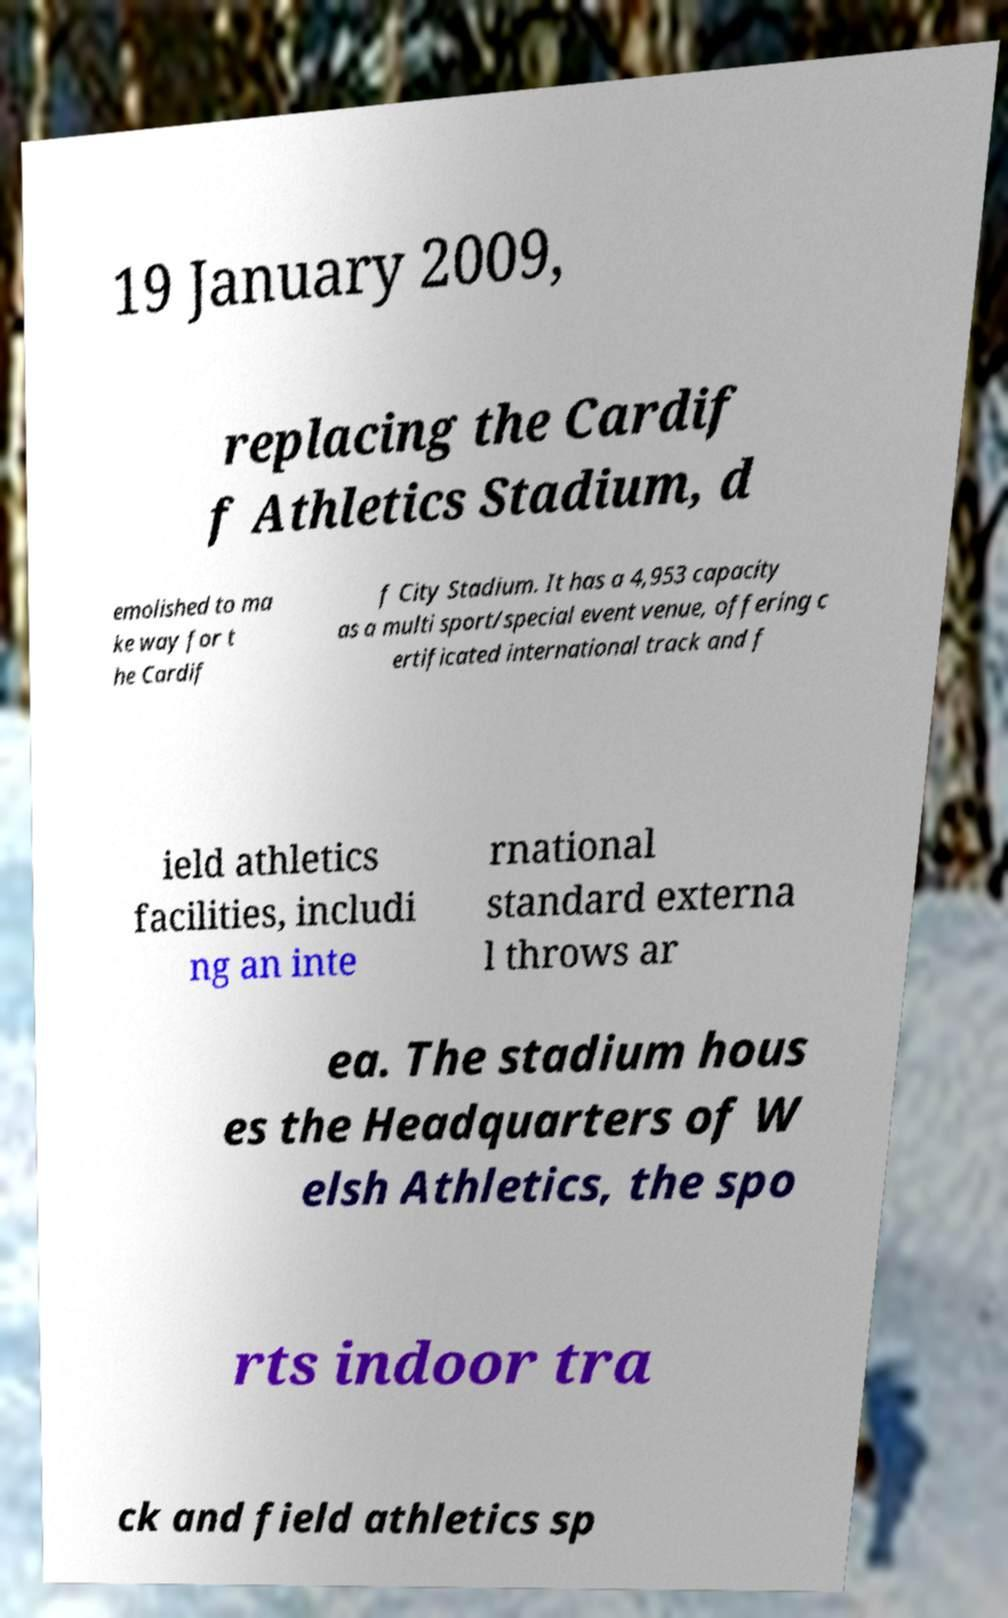Please read and relay the text visible in this image. What does it say? 19 January 2009, replacing the Cardif f Athletics Stadium, d emolished to ma ke way for t he Cardif f City Stadium. It has a 4,953 capacity as a multi sport/special event venue, offering c ertificated international track and f ield athletics facilities, includi ng an inte rnational standard externa l throws ar ea. The stadium hous es the Headquarters of W elsh Athletics, the spo rts indoor tra ck and field athletics sp 